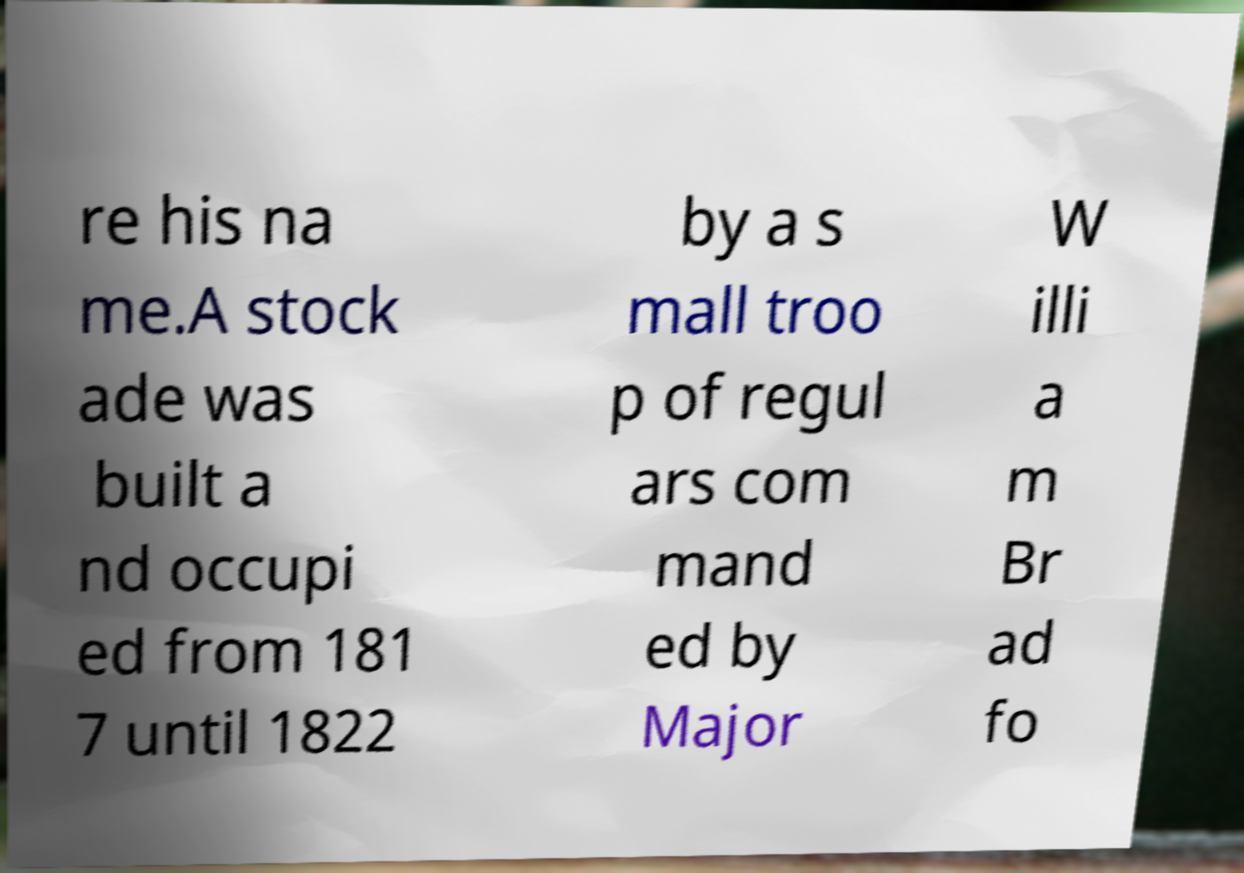There's text embedded in this image that I need extracted. Can you transcribe it verbatim? re his na me.A stock ade was built a nd occupi ed from 181 7 until 1822 by a s mall troo p of regul ars com mand ed by Major W illi a m Br ad fo 